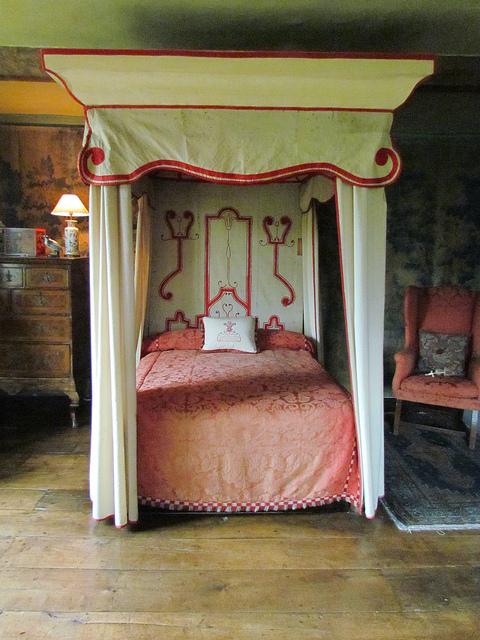How much taller is the canopy than the bed itself?
Concise answer only. 3 times. What color is the bed?
Keep it brief. Pink. Is this a single bed?
Give a very brief answer. Yes. Are there tassels on the bed frame?
Keep it brief. No. What color are the valances?
Give a very brief answer. White and red. Is the floor wood?
Short answer required. Yes. How many pillows are on the bed?
Keep it brief. 3. 